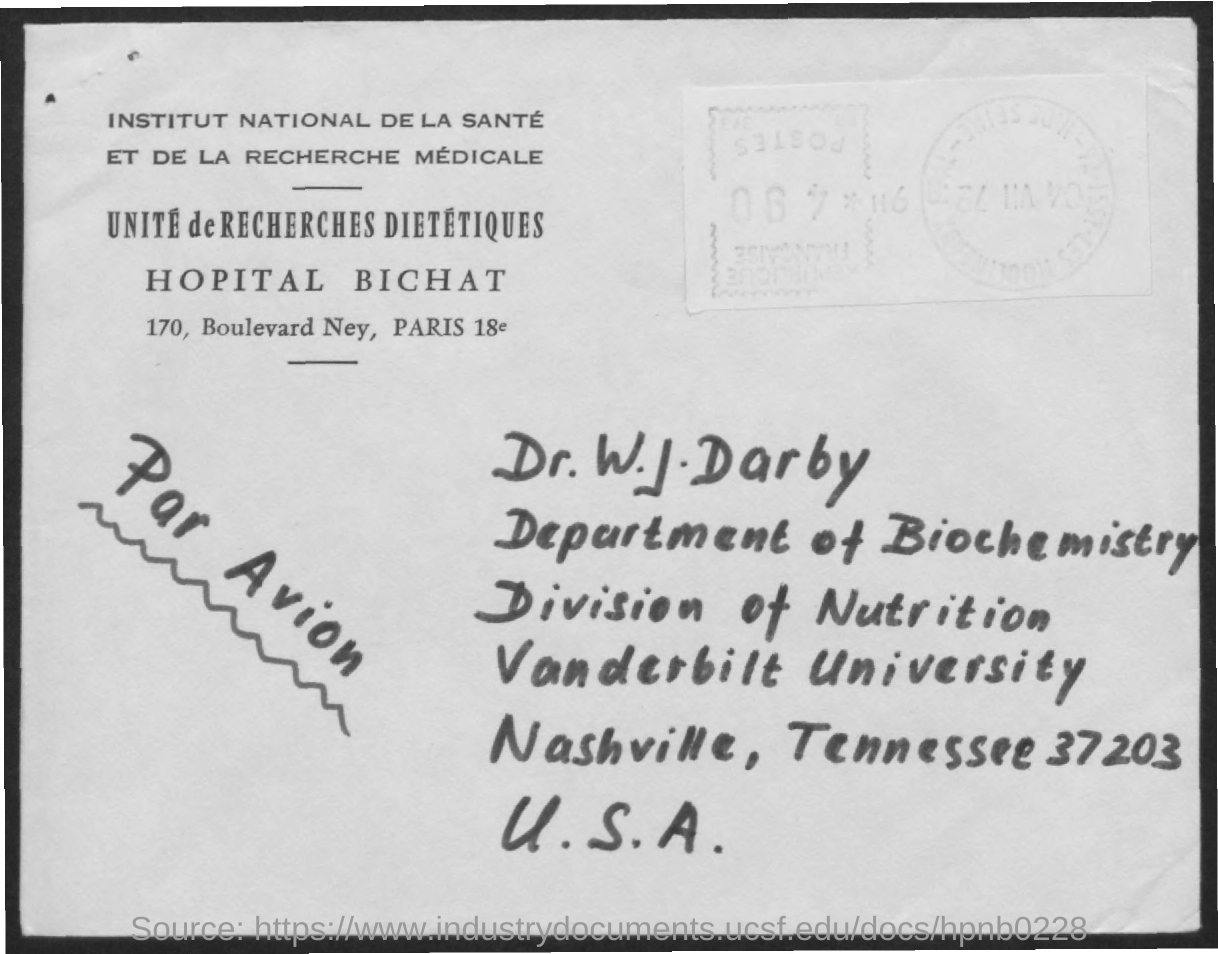List a handful of essential elements in this visual. Vanderbilt University is the specified university. The department mentioned in the address is the Department of Biochemistry. The zipcode specified is 37203. The addressee is Dr. W. J. Darby. What is the division specified? I'm talking about the division of Nutrition. 